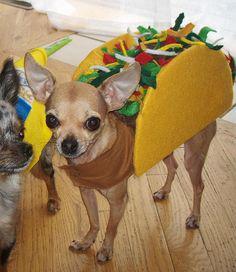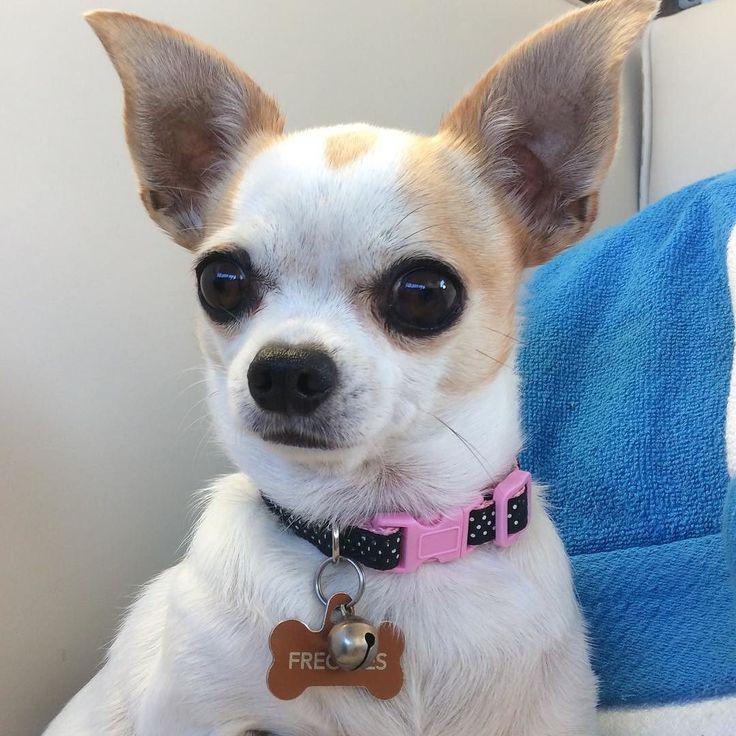The first image is the image on the left, the second image is the image on the right. Examine the images to the left and right. Is the description "At least one of the dogs is wearing a hat on it's head." accurate? Answer yes or no. No. The first image is the image on the left, the second image is the image on the right. Analyze the images presented: Is the assertion "A dog wears a hat in at least one image." valid? Answer yes or no. No. 